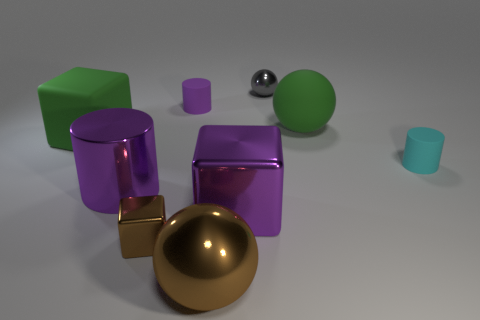How do the different materials of the objects affect the way light interacts with their surfaces? The materials of the objects have distinct properties that influence light interaction. The metallic objects reflect light strongly, creating clear reflections and highlights, while the matte surfaces of the rubber objects diffuse the light, resulting in softer, less defined reflections. 